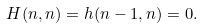Convert formula to latex. <formula><loc_0><loc_0><loc_500><loc_500>H ( n , n ) = h ( n - 1 , n ) = 0 .</formula> 